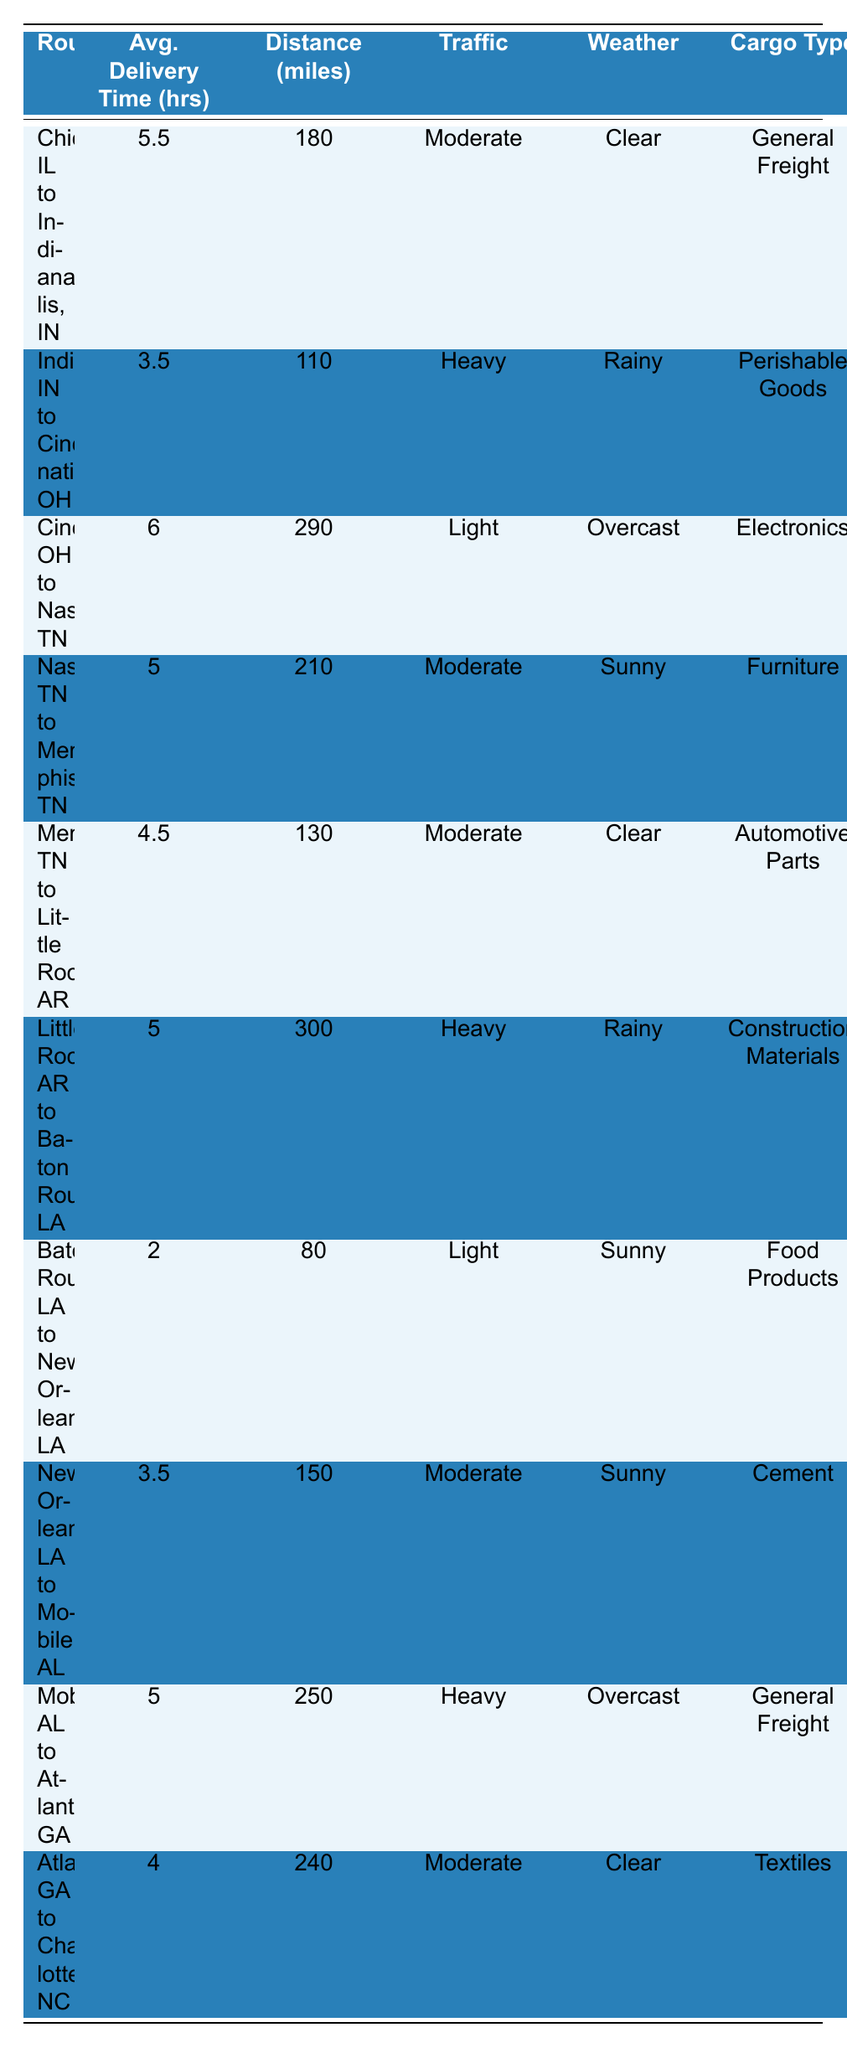What is the average delivery time from Chicago, IL to Indianapolis, IN? The table lists the average delivery time for this route as 5.5 hours.
Answer: 5.5 hours Which route has the shortest average delivery time? Looking at the average delivery times, the shortest time listed is for the route from Baton Rouge, LA to New Orleans, LA, which takes 2 hours.
Answer: Baton Rouge, LA to New Orleans, LA What is the average distance of all routes listed? To find the average distance, sum all the distances: 180 + 110 + 290 + 210 + 130 + 300 + 80 + 150 + 250 + 240 = 1,800 miles. Now divide by 10 (the number of routes): 1,800 / 10 = 180 miles.
Answer: 180 miles Is the weather typical for Nashville, TN to Memphis, TN sunny? According to the table, the typical weather for this route is marked as sunny, so the answer is yes.
Answer: Yes Which cargo type is transported from Indianapolis, IN to Cincinnati, OH? The cargo type for this route is perishable goods as stated in the table.
Answer: Perishable Goods What is the total average delivery time for routes that have heavy traffic conditions? The average delivery times for routes with heavy traffic are Indianapolis, IN to Cincinnati, OH (3.5 hours), Little Rock, AR to Baton Rouge, LA (5 hours), Mobile, AL to Atlanta, GA (5 hours). Adding these gives: 3.5 + 5 + 5 = 13.5 hours.
Answer: 13.5 hours Which route has the longest distance and what is that distance? The longest distance listed is from Cincinnati, OH to Nashville, TN, with a distance of 290 miles as per the table.
Answer: 290 miles Is the average delivery time for the route from New Orleans, LA to Mobile, AL more than 3 hours? The table states the average delivery time for this route is 3.5 hours, thus confirming it is more than 3 hours.
Answer: Yes How many routes have a typical weather condition that is clear? The routes with clear weather are Chicago, IL to Indianapolis, IN, Memphis, TN to Little Rock, AR, and Atlanta, GA to Charlotte, NC. Thus there are 3 routes with clear weather.
Answer: 3 